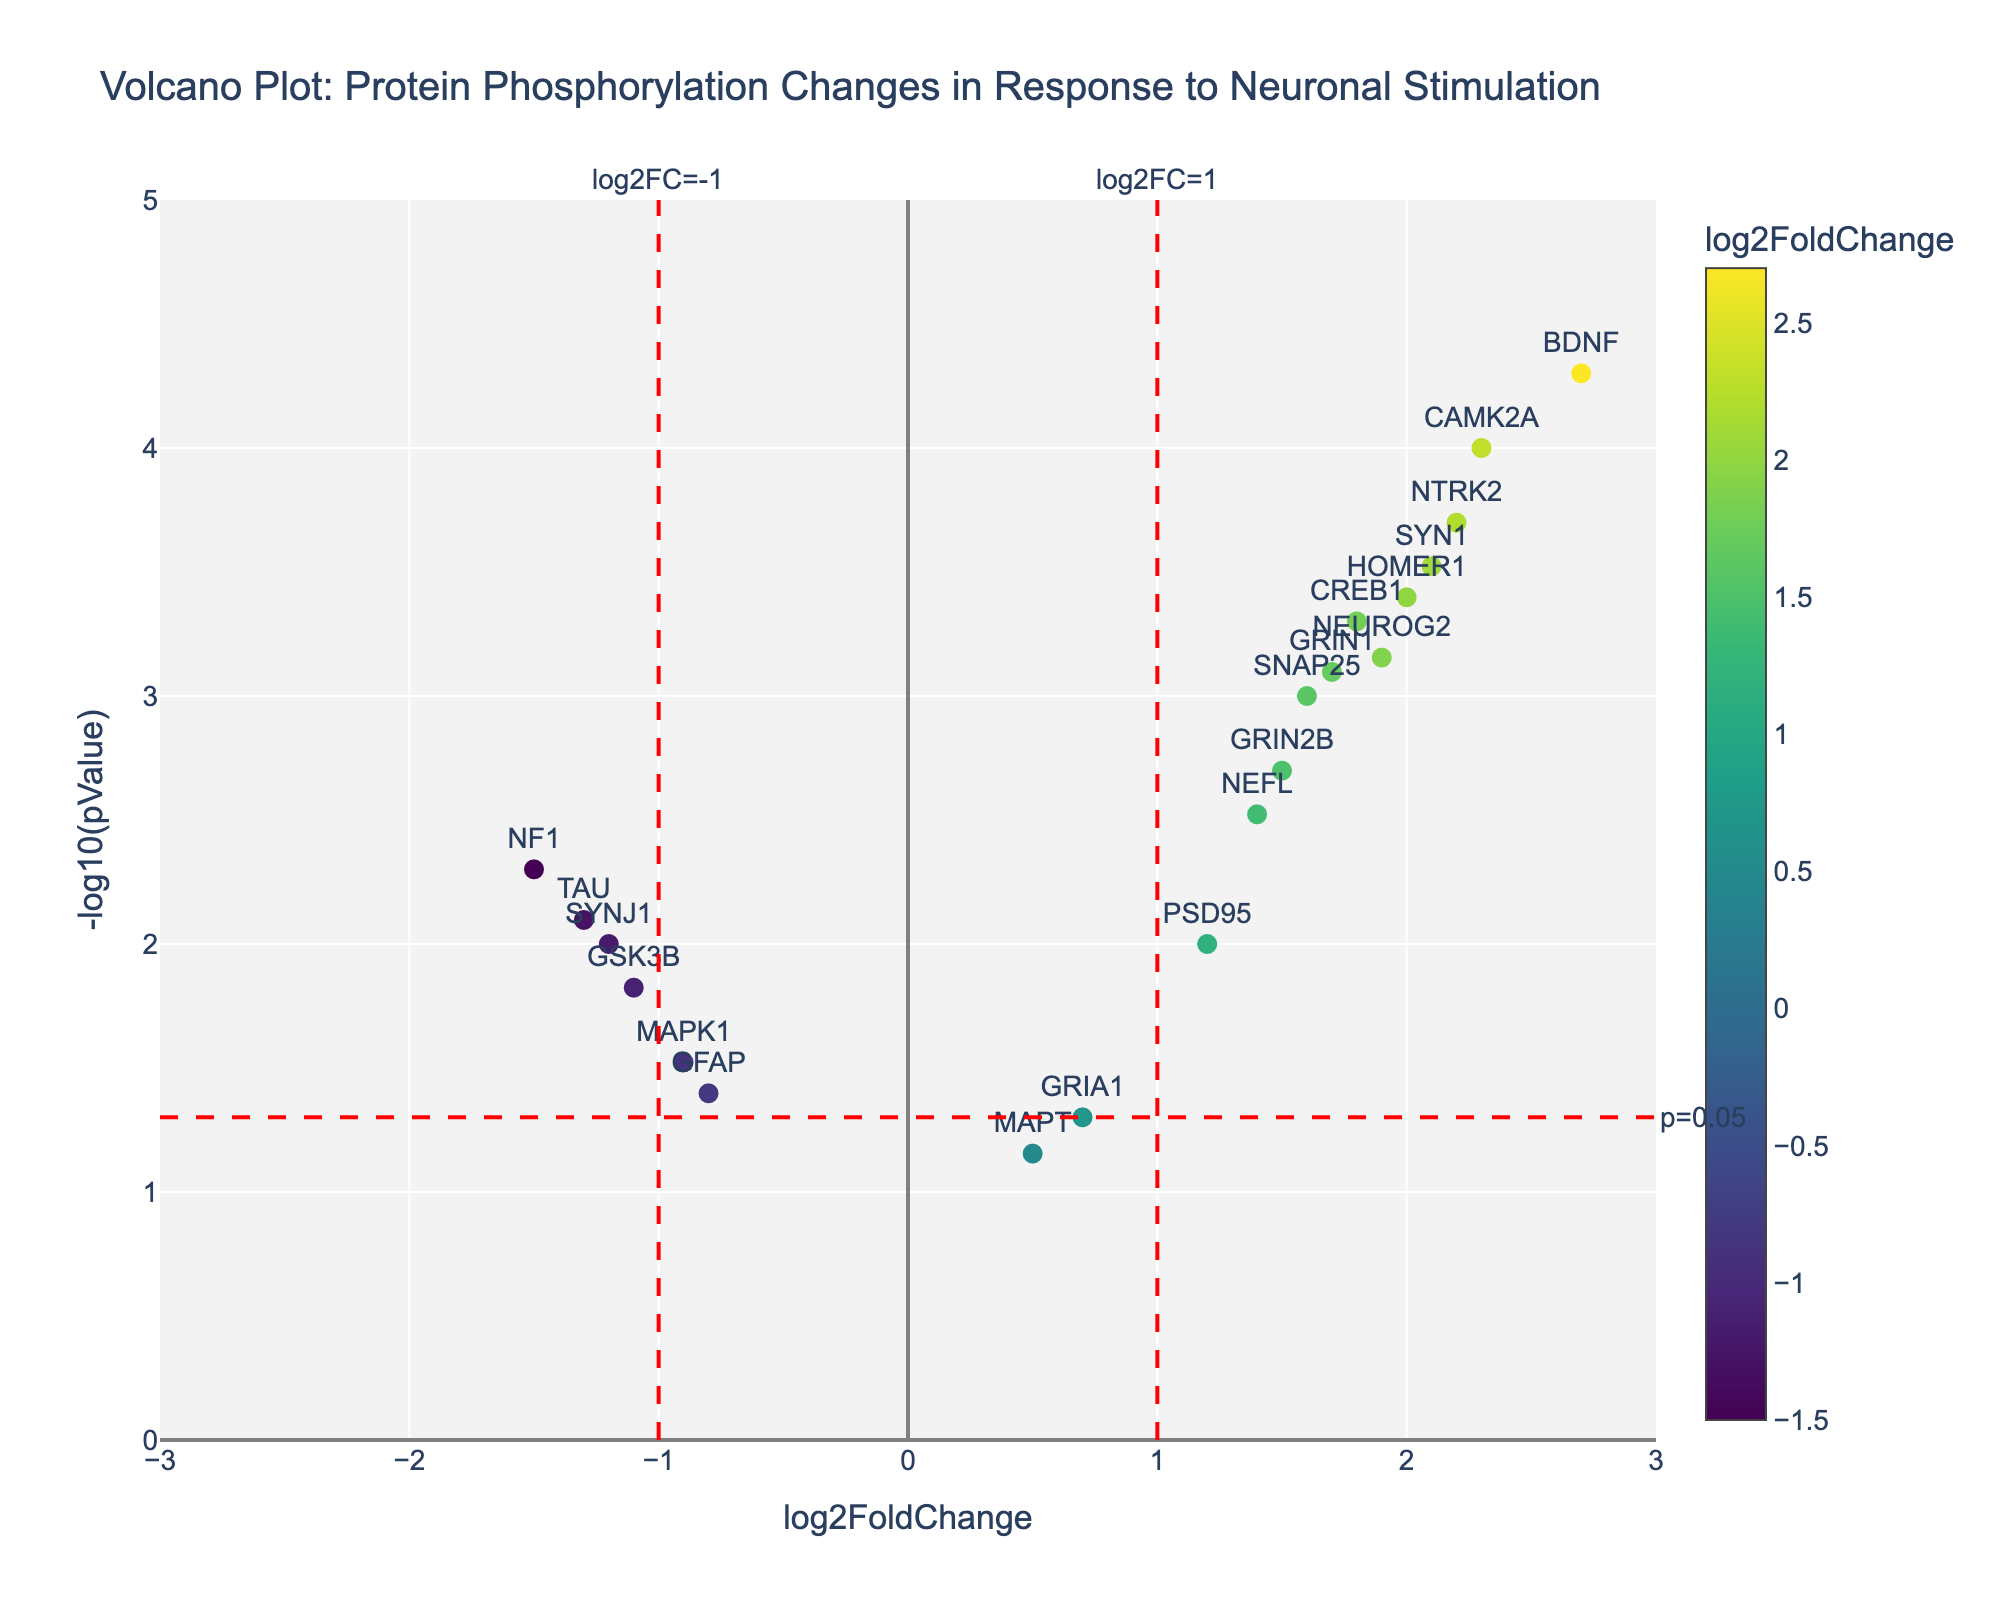What is the title of the plot? The title of the plot is typically found at the top and summarized for an overview.
Answer: Volcano Plot: Protein Phosphorylation Changes in Response to Neuronal Stimulation How many proteins have a log2FoldChange value greater than 2? Look at the x-axis, identify all points to the right of the vertical line at log2FoldChange value of 2.
Answer: 3 Which protein has the highest -log10(pValue)? Identify the highest point along the y-axis and read the corresponding label.
Answer: BDNF Identify proteins with a p-value below 0.001. Points with a y-coordinate above -log10(0.001), which equals 3, are highlighted. Identify and count these points.
Answer: CAMK2A, BDNF, SYN1, NTRK2, HOMER1 What does the red horizontal line signify? The horizontal line indicates the threshold of significance related to the p-value, at -log10(0.05).
Answer: p = 0.05 Which protein has the most significant downregulation? Identify the point with the most negative log2FoldChange and the highest -log10(pValue) corresponding to downregulation.
Answer: NF1 Are there any proteins near log2FoldChange = 0? Check the points around the vertical line labeled log2FC = 1, specifically in the range close to zero.
Answer: GRIA1, MAPT List proteins with both high fold change and high significance. Proteins in the top right area, beyond log2FoldChange ± 1, and above the red horizontal line for significance.
Answer: CAMK2A, SYN1, BDNF, HOMER1, NTRK2 What is the log2FoldChange for CREB1? Find the label "CREB1" and note the x-coordinate value.
Answer: 1.8 Which protein shows non-significant changes in response to neuronal stimulation? Focus on points below the horizontal line indicating the threshold (y < 1.3, -log10(0.05)) to identify proteins with non-significant changes.
Answer: GRIA1, GFAP, MAPT 